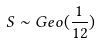Convert formula to latex. <formula><loc_0><loc_0><loc_500><loc_500>S \sim G e o ( \frac { 1 } { 1 2 } )</formula> 